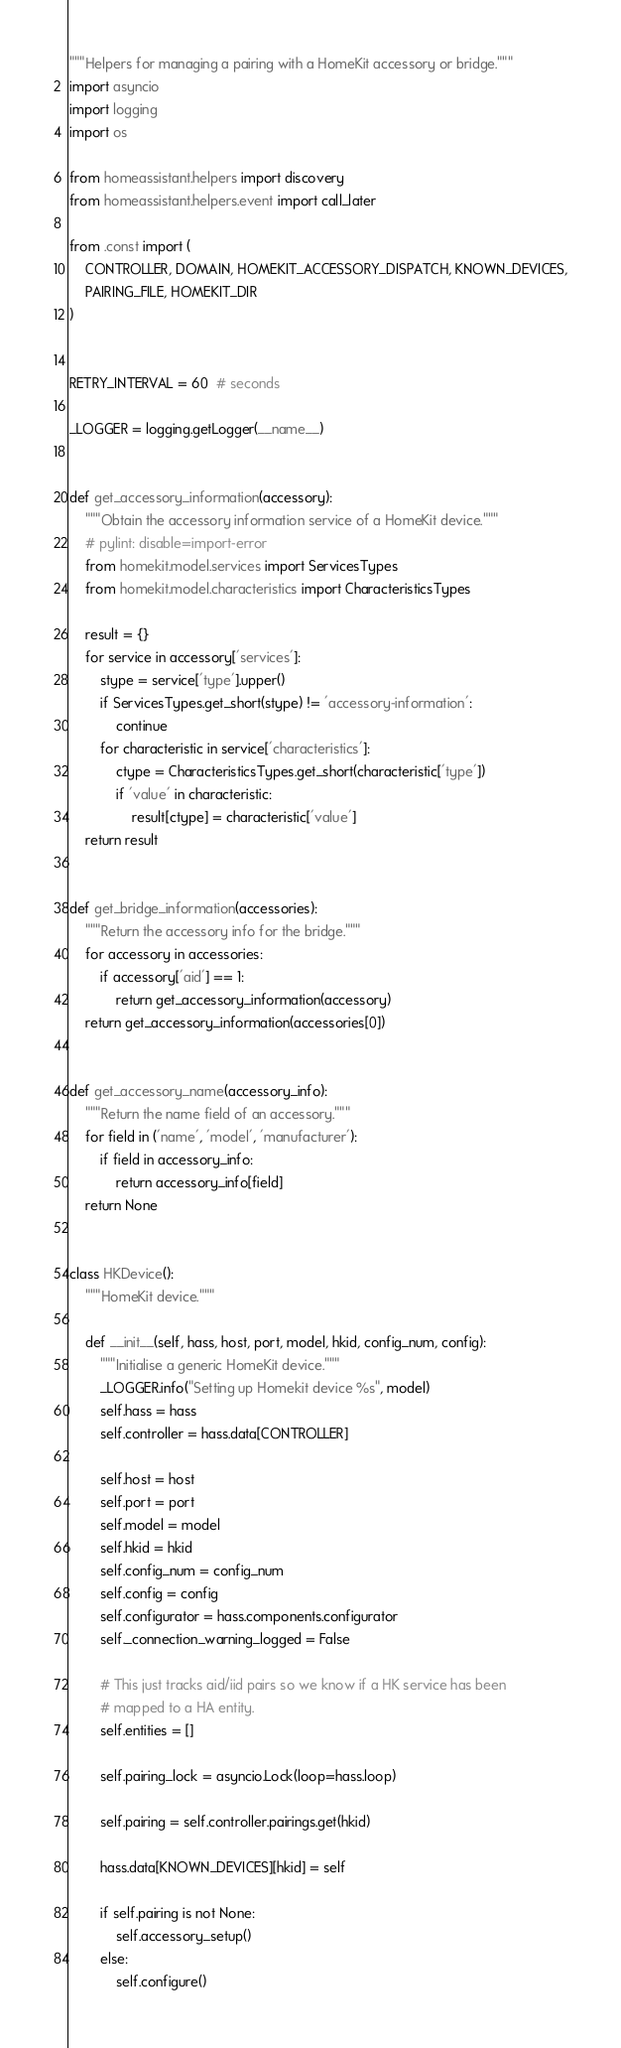<code> <loc_0><loc_0><loc_500><loc_500><_Python_>"""Helpers for managing a pairing with a HomeKit accessory or bridge."""
import asyncio
import logging
import os

from homeassistant.helpers import discovery
from homeassistant.helpers.event import call_later

from .const import (
    CONTROLLER, DOMAIN, HOMEKIT_ACCESSORY_DISPATCH, KNOWN_DEVICES,
    PAIRING_FILE, HOMEKIT_DIR
)


RETRY_INTERVAL = 60  # seconds

_LOGGER = logging.getLogger(__name__)


def get_accessory_information(accessory):
    """Obtain the accessory information service of a HomeKit device."""
    # pylint: disable=import-error
    from homekit.model.services import ServicesTypes
    from homekit.model.characteristics import CharacteristicsTypes

    result = {}
    for service in accessory['services']:
        stype = service['type'].upper()
        if ServicesTypes.get_short(stype) != 'accessory-information':
            continue
        for characteristic in service['characteristics']:
            ctype = CharacteristicsTypes.get_short(characteristic['type'])
            if 'value' in characteristic:
                result[ctype] = characteristic['value']
    return result


def get_bridge_information(accessories):
    """Return the accessory info for the bridge."""
    for accessory in accessories:
        if accessory['aid'] == 1:
            return get_accessory_information(accessory)
    return get_accessory_information(accessories[0])


def get_accessory_name(accessory_info):
    """Return the name field of an accessory."""
    for field in ('name', 'model', 'manufacturer'):
        if field in accessory_info:
            return accessory_info[field]
    return None


class HKDevice():
    """HomeKit device."""

    def __init__(self, hass, host, port, model, hkid, config_num, config):
        """Initialise a generic HomeKit device."""
        _LOGGER.info("Setting up Homekit device %s", model)
        self.hass = hass
        self.controller = hass.data[CONTROLLER]

        self.host = host
        self.port = port
        self.model = model
        self.hkid = hkid
        self.config_num = config_num
        self.config = config
        self.configurator = hass.components.configurator
        self._connection_warning_logged = False

        # This just tracks aid/iid pairs so we know if a HK service has been
        # mapped to a HA entity.
        self.entities = []

        self.pairing_lock = asyncio.Lock(loop=hass.loop)

        self.pairing = self.controller.pairings.get(hkid)

        hass.data[KNOWN_DEVICES][hkid] = self

        if self.pairing is not None:
            self.accessory_setup()
        else:
            self.configure()
</code> 